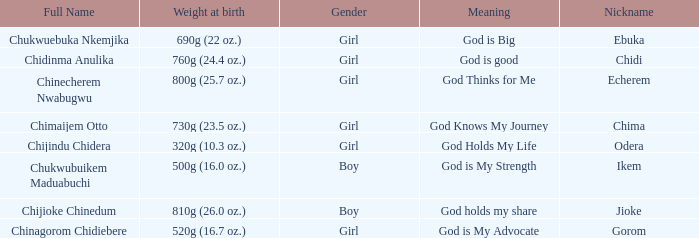What nickname has the meaning of God knows my journey? Chima. 